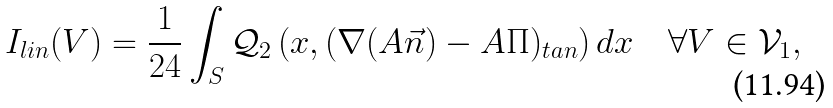Convert formula to latex. <formula><loc_0><loc_0><loc_500><loc_500>I _ { l i n } ( V ) = \frac { 1 } { 2 4 } \int _ { S } \mathcal { Q } _ { 2 } \left ( x , ( \nabla ( A \vec { n } ) - A \Pi ) _ { t a n } \right ) d x \quad \forall V \in \mathcal { V } _ { 1 } ,</formula> 